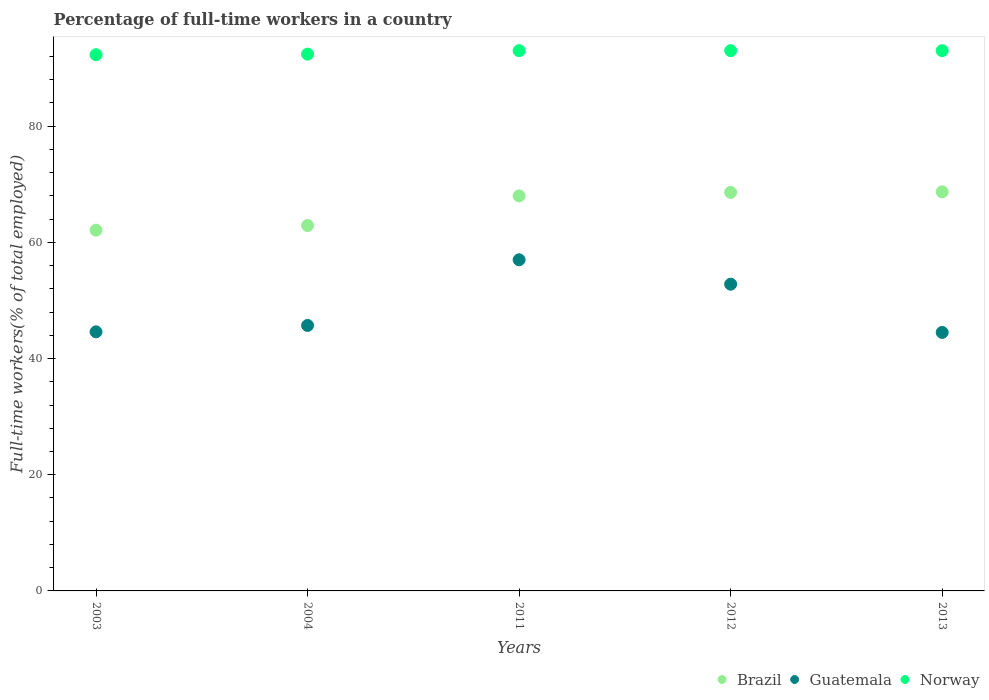What is the percentage of full-time workers in Norway in 2013?
Provide a short and direct response. 93. Across all years, what is the maximum percentage of full-time workers in Guatemala?
Provide a succinct answer. 57. Across all years, what is the minimum percentage of full-time workers in Guatemala?
Your answer should be compact. 44.5. What is the total percentage of full-time workers in Guatemala in the graph?
Ensure brevity in your answer.  244.6. What is the difference between the percentage of full-time workers in Brazil in 2011 and that in 2012?
Provide a succinct answer. -0.6. What is the difference between the percentage of full-time workers in Brazil in 2004 and the percentage of full-time workers in Norway in 2003?
Your response must be concise. -29.4. What is the average percentage of full-time workers in Guatemala per year?
Provide a succinct answer. 48.92. In the year 2012, what is the difference between the percentage of full-time workers in Guatemala and percentage of full-time workers in Brazil?
Provide a succinct answer. -15.8. In how many years, is the percentage of full-time workers in Norway greater than 24 %?
Make the answer very short. 5. What is the ratio of the percentage of full-time workers in Norway in 2011 to that in 2012?
Your answer should be very brief. 1. Is the percentage of full-time workers in Norway in 2003 less than that in 2011?
Make the answer very short. Yes. Is the difference between the percentage of full-time workers in Guatemala in 2012 and 2013 greater than the difference between the percentage of full-time workers in Brazil in 2012 and 2013?
Provide a succinct answer. Yes. What is the difference between the highest and the lowest percentage of full-time workers in Brazil?
Make the answer very short. 6.6. In how many years, is the percentage of full-time workers in Norway greater than the average percentage of full-time workers in Norway taken over all years?
Provide a short and direct response. 3. Is it the case that in every year, the sum of the percentage of full-time workers in Guatemala and percentage of full-time workers in Norway  is greater than the percentage of full-time workers in Brazil?
Your response must be concise. Yes. What is the difference between two consecutive major ticks on the Y-axis?
Provide a short and direct response. 20. Where does the legend appear in the graph?
Offer a very short reply. Bottom right. What is the title of the graph?
Your answer should be compact. Percentage of full-time workers in a country. What is the label or title of the Y-axis?
Give a very brief answer. Full-time workers(% of total employed). What is the Full-time workers(% of total employed) in Brazil in 2003?
Provide a short and direct response. 62.1. What is the Full-time workers(% of total employed) of Guatemala in 2003?
Give a very brief answer. 44.6. What is the Full-time workers(% of total employed) of Norway in 2003?
Provide a short and direct response. 92.3. What is the Full-time workers(% of total employed) of Brazil in 2004?
Your response must be concise. 62.9. What is the Full-time workers(% of total employed) in Guatemala in 2004?
Offer a terse response. 45.7. What is the Full-time workers(% of total employed) of Norway in 2004?
Provide a short and direct response. 92.4. What is the Full-time workers(% of total employed) in Norway in 2011?
Keep it short and to the point. 93. What is the Full-time workers(% of total employed) of Brazil in 2012?
Make the answer very short. 68.6. What is the Full-time workers(% of total employed) in Guatemala in 2012?
Ensure brevity in your answer.  52.8. What is the Full-time workers(% of total employed) in Norway in 2012?
Give a very brief answer. 93. What is the Full-time workers(% of total employed) of Brazil in 2013?
Your answer should be very brief. 68.7. What is the Full-time workers(% of total employed) in Guatemala in 2013?
Your answer should be compact. 44.5. What is the Full-time workers(% of total employed) of Norway in 2013?
Give a very brief answer. 93. Across all years, what is the maximum Full-time workers(% of total employed) in Brazil?
Your response must be concise. 68.7. Across all years, what is the maximum Full-time workers(% of total employed) of Guatemala?
Provide a short and direct response. 57. Across all years, what is the maximum Full-time workers(% of total employed) of Norway?
Your answer should be very brief. 93. Across all years, what is the minimum Full-time workers(% of total employed) in Brazil?
Make the answer very short. 62.1. Across all years, what is the minimum Full-time workers(% of total employed) of Guatemala?
Your answer should be very brief. 44.5. Across all years, what is the minimum Full-time workers(% of total employed) of Norway?
Your response must be concise. 92.3. What is the total Full-time workers(% of total employed) in Brazil in the graph?
Keep it short and to the point. 330.3. What is the total Full-time workers(% of total employed) in Guatemala in the graph?
Offer a very short reply. 244.6. What is the total Full-time workers(% of total employed) in Norway in the graph?
Your answer should be very brief. 463.7. What is the difference between the Full-time workers(% of total employed) in Brazil in 2003 and that in 2004?
Your response must be concise. -0.8. What is the difference between the Full-time workers(% of total employed) in Guatemala in 2003 and that in 2011?
Your response must be concise. -12.4. What is the difference between the Full-time workers(% of total employed) of Norway in 2003 and that in 2011?
Make the answer very short. -0.7. What is the difference between the Full-time workers(% of total employed) in Norway in 2003 and that in 2012?
Provide a succinct answer. -0.7. What is the difference between the Full-time workers(% of total employed) in Brazil in 2003 and that in 2013?
Give a very brief answer. -6.6. What is the difference between the Full-time workers(% of total employed) of Guatemala in 2003 and that in 2013?
Offer a terse response. 0.1. What is the difference between the Full-time workers(% of total employed) of Guatemala in 2004 and that in 2011?
Provide a short and direct response. -11.3. What is the difference between the Full-time workers(% of total employed) in Norway in 2004 and that in 2011?
Keep it short and to the point. -0.6. What is the difference between the Full-time workers(% of total employed) of Norway in 2004 and that in 2012?
Your response must be concise. -0.6. What is the difference between the Full-time workers(% of total employed) of Brazil in 2004 and that in 2013?
Keep it short and to the point. -5.8. What is the difference between the Full-time workers(% of total employed) of Norway in 2004 and that in 2013?
Provide a succinct answer. -0.6. What is the difference between the Full-time workers(% of total employed) of Brazil in 2011 and that in 2012?
Provide a succinct answer. -0.6. What is the difference between the Full-time workers(% of total employed) of Norway in 2011 and that in 2012?
Offer a terse response. 0. What is the difference between the Full-time workers(% of total employed) in Brazil in 2011 and that in 2013?
Provide a short and direct response. -0.7. What is the difference between the Full-time workers(% of total employed) in Guatemala in 2011 and that in 2013?
Your response must be concise. 12.5. What is the difference between the Full-time workers(% of total employed) in Norway in 2011 and that in 2013?
Make the answer very short. 0. What is the difference between the Full-time workers(% of total employed) in Brazil in 2012 and that in 2013?
Offer a terse response. -0.1. What is the difference between the Full-time workers(% of total employed) in Norway in 2012 and that in 2013?
Make the answer very short. 0. What is the difference between the Full-time workers(% of total employed) of Brazil in 2003 and the Full-time workers(% of total employed) of Norway in 2004?
Keep it short and to the point. -30.3. What is the difference between the Full-time workers(% of total employed) in Guatemala in 2003 and the Full-time workers(% of total employed) in Norway in 2004?
Make the answer very short. -47.8. What is the difference between the Full-time workers(% of total employed) of Brazil in 2003 and the Full-time workers(% of total employed) of Norway in 2011?
Provide a succinct answer. -30.9. What is the difference between the Full-time workers(% of total employed) in Guatemala in 2003 and the Full-time workers(% of total employed) in Norway in 2011?
Provide a succinct answer. -48.4. What is the difference between the Full-time workers(% of total employed) of Brazil in 2003 and the Full-time workers(% of total employed) of Guatemala in 2012?
Ensure brevity in your answer.  9.3. What is the difference between the Full-time workers(% of total employed) of Brazil in 2003 and the Full-time workers(% of total employed) of Norway in 2012?
Offer a terse response. -30.9. What is the difference between the Full-time workers(% of total employed) in Guatemala in 2003 and the Full-time workers(% of total employed) in Norway in 2012?
Your answer should be compact. -48.4. What is the difference between the Full-time workers(% of total employed) of Brazil in 2003 and the Full-time workers(% of total employed) of Guatemala in 2013?
Your answer should be compact. 17.6. What is the difference between the Full-time workers(% of total employed) of Brazil in 2003 and the Full-time workers(% of total employed) of Norway in 2013?
Provide a succinct answer. -30.9. What is the difference between the Full-time workers(% of total employed) in Guatemala in 2003 and the Full-time workers(% of total employed) in Norway in 2013?
Your answer should be very brief. -48.4. What is the difference between the Full-time workers(% of total employed) in Brazil in 2004 and the Full-time workers(% of total employed) in Norway in 2011?
Your response must be concise. -30.1. What is the difference between the Full-time workers(% of total employed) in Guatemala in 2004 and the Full-time workers(% of total employed) in Norway in 2011?
Ensure brevity in your answer.  -47.3. What is the difference between the Full-time workers(% of total employed) of Brazil in 2004 and the Full-time workers(% of total employed) of Norway in 2012?
Your answer should be compact. -30.1. What is the difference between the Full-time workers(% of total employed) of Guatemala in 2004 and the Full-time workers(% of total employed) of Norway in 2012?
Offer a very short reply. -47.3. What is the difference between the Full-time workers(% of total employed) of Brazil in 2004 and the Full-time workers(% of total employed) of Norway in 2013?
Offer a terse response. -30.1. What is the difference between the Full-time workers(% of total employed) of Guatemala in 2004 and the Full-time workers(% of total employed) of Norway in 2013?
Your response must be concise. -47.3. What is the difference between the Full-time workers(% of total employed) of Brazil in 2011 and the Full-time workers(% of total employed) of Guatemala in 2012?
Make the answer very short. 15.2. What is the difference between the Full-time workers(% of total employed) in Guatemala in 2011 and the Full-time workers(% of total employed) in Norway in 2012?
Give a very brief answer. -36. What is the difference between the Full-time workers(% of total employed) in Brazil in 2011 and the Full-time workers(% of total employed) in Guatemala in 2013?
Your answer should be very brief. 23.5. What is the difference between the Full-time workers(% of total employed) of Brazil in 2011 and the Full-time workers(% of total employed) of Norway in 2013?
Your answer should be compact. -25. What is the difference between the Full-time workers(% of total employed) of Guatemala in 2011 and the Full-time workers(% of total employed) of Norway in 2013?
Provide a short and direct response. -36. What is the difference between the Full-time workers(% of total employed) of Brazil in 2012 and the Full-time workers(% of total employed) of Guatemala in 2013?
Offer a very short reply. 24.1. What is the difference between the Full-time workers(% of total employed) of Brazil in 2012 and the Full-time workers(% of total employed) of Norway in 2013?
Keep it short and to the point. -24.4. What is the difference between the Full-time workers(% of total employed) in Guatemala in 2012 and the Full-time workers(% of total employed) in Norway in 2013?
Ensure brevity in your answer.  -40.2. What is the average Full-time workers(% of total employed) of Brazil per year?
Provide a short and direct response. 66.06. What is the average Full-time workers(% of total employed) in Guatemala per year?
Give a very brief answer. 48.92. What is the average Full-time workers(% of total employed) of Norway per year?
Your answer should be compact. 92.74. In the year 2003, what is the difference between the Full-time workers(% of total employed) in Brazil and Full-time workers(% of total employed) in Guatemala?
Provide a short and direct response. 17.5. In the year 2003, what is the difference between the Full-time workers(% of total employed) in Brazil and Full-time workers(% of total employed) in Norway?
Make the answer very short. -30.2. In the year 2003, what is the difference between the Full-time workers(% of total employed) in Guatemala and Full-time workers(% of total employed) in Norway?
Make the answer very short. -47.7. In the year 2004, what is the difference between the Full-time workers(% of total employed) of Brazil and Full-time workers(% of total employed) of Guatemala?
Ensure brevity in your answer.  17.2. In the year 2004, what is the difference between the Full-time workers(% of total employed) of Brazil and Full-time workers(% of total employed) of Norway?
Keep it short and to the point. -29.5. In the year 2004, what is the difference between the Full-time workers(% of total employed) in Guatemala and Full-time workers(% of total employed) in Norway?
Provide a short and direct response. -46.7. In the year 2011, what is the difference between the Full-time workers(% of total employed) in Brazil and Full-time workers(% of total employed) in Guatemala?
Ensure brevity in your answer.  11. In the year 2011, what is the difference between the Full-time workers(% of total employed) in Brazil and Full-time workers(% of total employed) in Norway?
Provide a short and direct response. -25. In the year 2011, what is the difference between the Full-time workers(% of total employed) in Guatemala and Full-time workers(% of total employed) in Norway?
Offer a terse response. -36. In the year 2012, what is the difference between the Full-time workers(% of total employed) of Brazil and Full-time workers(% of total employed) of Norway?
Your answer should be very brief. -24.4. In the year 2012, what is the difference between the Full-time workers(% of total employed) in Guatemala and Full-time workers(% of total employed) in Norway?
Your answer should be compact. -40.2. In the year 2013, what is the difference between the Full-time workers(% of total employed) of Brazil and Full-time workers(% of total employed) of Guatemala?
Your answer should be very brief. 24.2. In the year 2013, what is the difference between the Full-time workers(% of total employed) in Brazil and Full-time workers(% of total employed) in Norway?
Provide a short and direct response. -24.3. In the year 2013, what is the difference between the Full-time workers(% of total employed) of Guatemala and Full-time workers(% of total employed) of Norway?
Offer a terse response. -48.5. What is the ratio of the Full-time workers(% of total employed) in Brazil in 2003 to that in 2004?
Your answer should be very brief. 0.99. What is the ratio of the Full-time workers(% of total employed) of Guatemala in 2003 to that in 2004?
Your answer should be compact. 0.98. What is the ratio of the Full-time workers(% of total employed) of Norway in 2003 to that in 2004?
Ensure brevity in your answer.  1. What is the ratio of the Full-time workers(% of total employed) of Brazil in 2003 to that in 2011?
Your response must be concise. 0.91. What is the ratio of the Full-time workers(% of total employed) of Guatemala in 2003 to that in 2011?
Your answer should be very brief. 0.78. What is the ratio of the Full-time workers(% of total employed) in Brazil in 2003 to that in 2012?
Your answer should be compact. 0.91. What is the ratio of the Full-time workers(% of total employed) of Guatemala in 2003 to that in 2012?
Provide a short and direct response. 0.84. What is the ratio of the Full-time workers(% of total employed) of Brazil in 2003 to that in 2013?
Provide a succinct answer. 0.9. What is the ratio of the Full-time workers(% of total employed) of Brazil in 2004 to that in 2011?
Keep it short and to the point. 0.93. What is the ratio of the Full-time workers(% of total employed) in Guatemala in 2004 to that in 2011?
Provide a short and direct response. 0.8. What is the ratio of the Full-time workers(% of total employed) of Norway in 2004 to that in 2011?
Provide a succinct answer. 0.99. What is the ratio of the Full-time workers(% of total employed) in Brazil in 2004 to that in 2012?
Provide a succinct answer. 0.92. What is the ratio of the Full-time workers(% of total employed) of Guatemala in 2004 to that in 2012?
Ensure brevity in your answer.  0.87. What is the ratio of the Full-time workers(% of total employed) in Brazil in 2004 to that in 2013?
Your answer should be very brief. 0.92. What is the ratio of the Full-time workers(% of total employed) of Norway in 2004 to that in 2013?
Make the answer very short. 0.99. What is the ratio of the Full-time workers(% of total employed) in Guatemala in 2011 to that in 2012?
Provide a short and direct response. 1.08. What is the ratio of the Full-time workers(% of total employed) in Norway in 2011 to that in 2012?
Offer a terse response. 1. What is the ratio of the Full-time workers(% of total employed) in Guatemala in 2011 to that in 2013?
Provide a short and direct response. 1.28. What is the ratio of the Full-time workers(% of total employed) in Norway in 2011 to that in 2013?
Ensure brevity in your answer.  1. What is the ratio of the Full-time workers(% of total employed) in Guatemala in 2012 to that in 2013?
Your answer should be very brief. 1.19. What is the difference between the highest and the lowest Full-time workers(% of total employed) in Brazil?
Offer a very short reply. 6.6. 